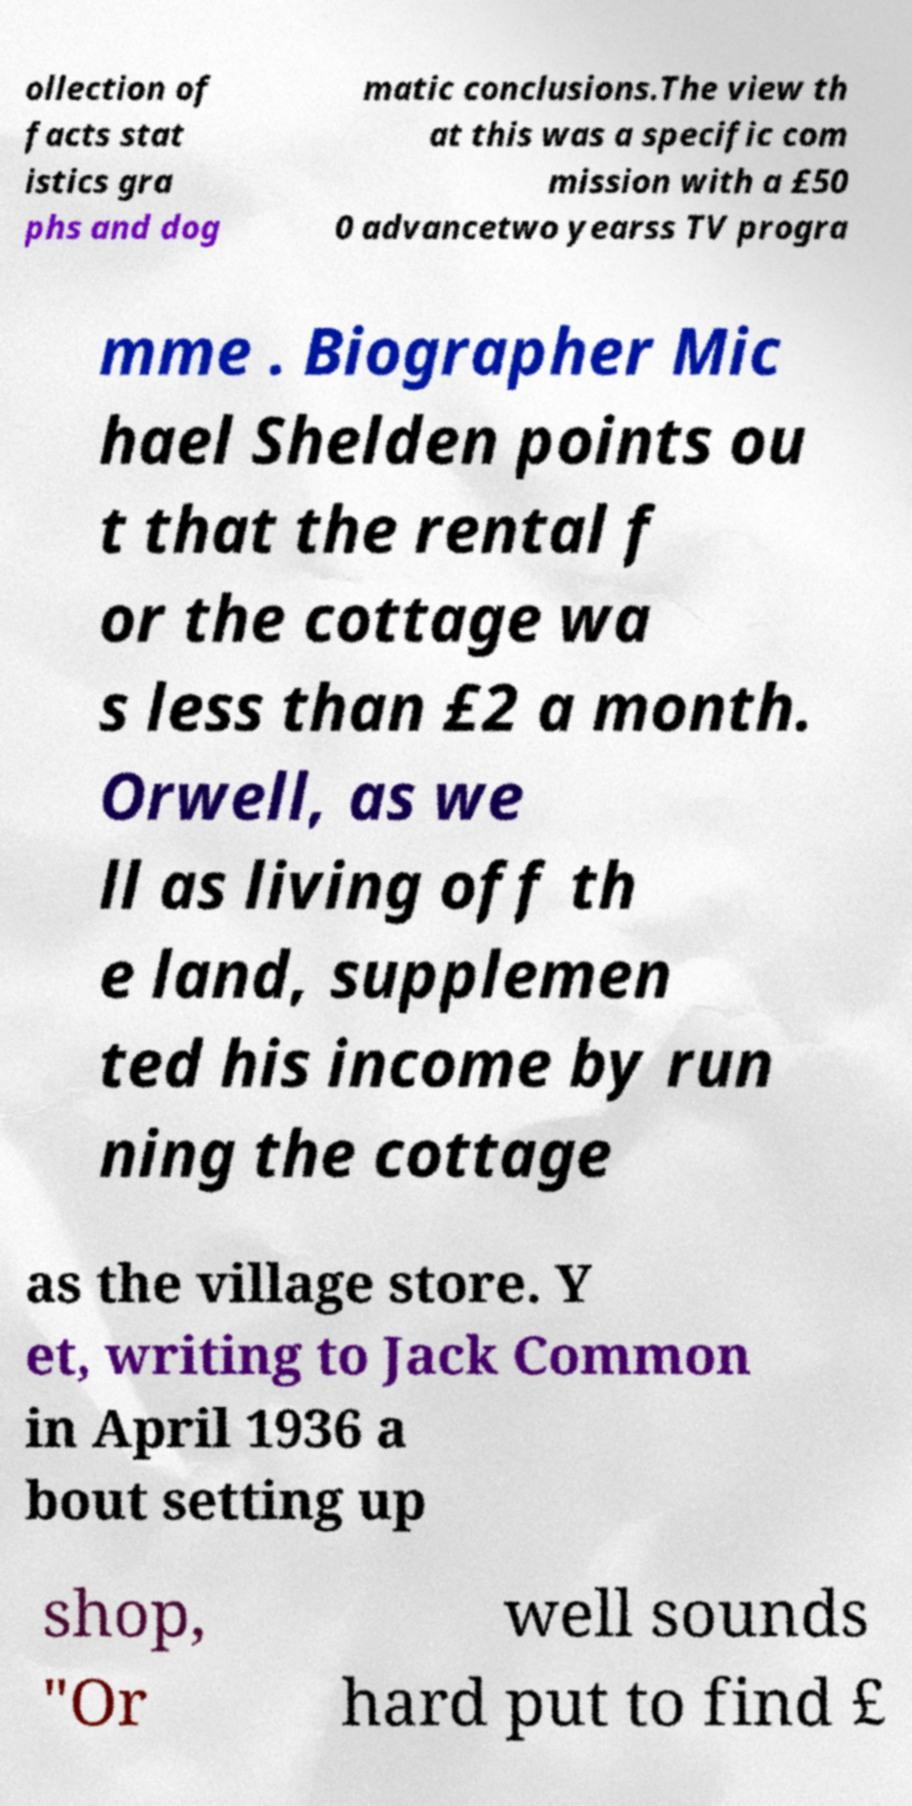There's text embedded in this image that I need extracted. Can you transcribe it verbatim? ollection of facts stat istics gra phs and dog matic conclusions.The view th at this was a specific com mission with a £50 0 advancetwo yearss TV progra mme . Biographer Mic hael Shelden points ou t that the rental f or the cottage wa s less than £2 a month. Orwell, as we ll as living off th e land, supplemen ted his income by run ning the cottage as the village store. Y et, writing to Jack Common in April 1936 a bout setting up shop, "Or well sounds hard put to find £ 